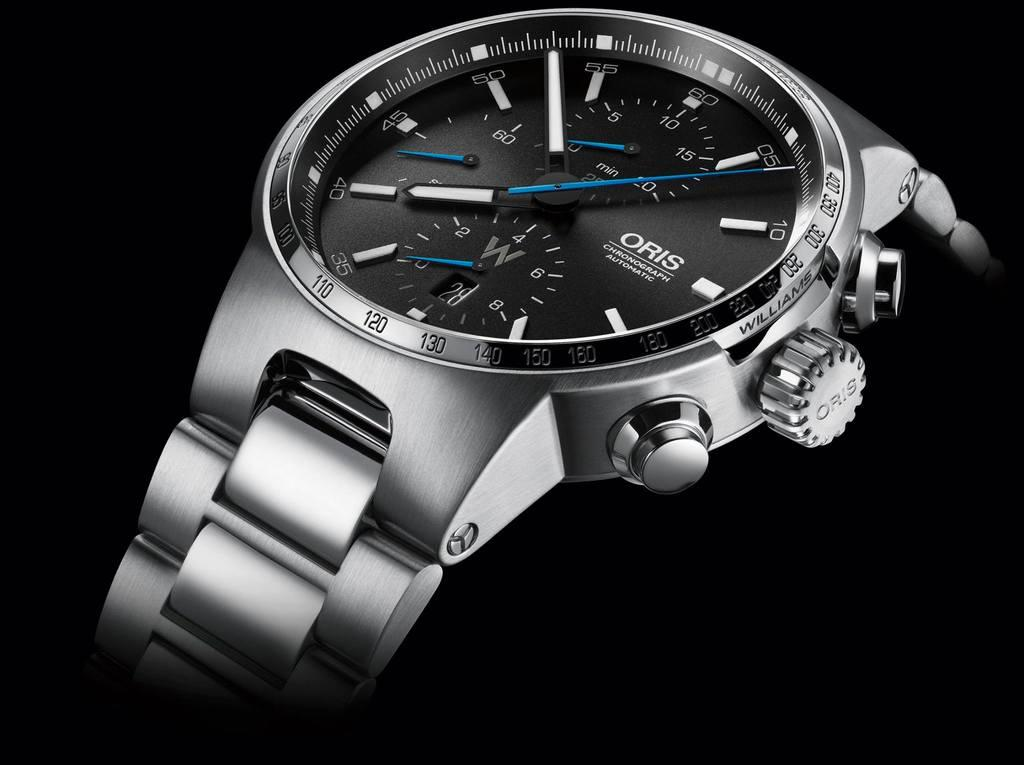What object is the main subject of the image? There is a watch in the image. What is the color of the watch? The watch is silver in color. What color is the dial of the watch? The dial of the watch is black. What is the color of the background in the image? There is a black background in the image. How many bushes are visible in the image? There are no bushes present in the image; it features a watch with a black dial and a silver body against a black background. What type of pie is being served on the watch in the image? There is no pie present in the image; it only features a watch with a black dial and a silver body against a black background. 